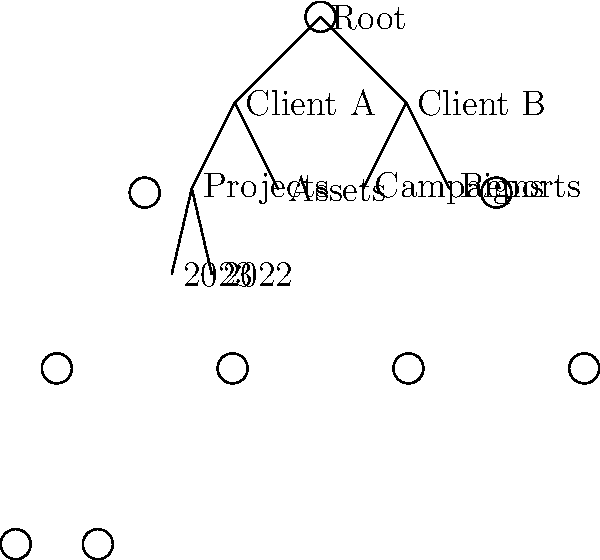In the given tree diagram representing a cloud storage system for a digital marketing agency, what is the total number of folders at the third level of the hierarchy? To answer this question, we need to analyze the tree diagram and understand its structure:

1. The root level (level 0) contains the "Root" folder.
2. The first level (level 1) contains "Client A" and "Client B" folders.
3. The second level (level 2) contains "Projects", "Assets", "Campaigns", and "Reports" folders.
4. The third level (level 3) contains "2023" and "2022" folders.

To find the total number of folders at the third level:

1. Identify all branches that extend to the third level.
2. Count the number of folders at this level.

In this diagram, we can see that only the "Projects" folder under "Client A" has subfolders at the third level, which are "2023" and "2022".

Therefore, the total number of folders at the third level is 2.
Answer: 2 